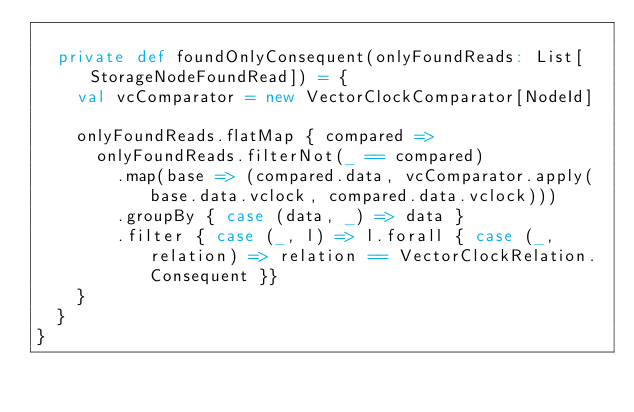Convert code to text. <code><loc_0><loc_0><loc_500><loc_500><_Scala_>
  private def foundOnlyConsequent(onlyFoundReads: List[StorageNodeFoundRead]) = {
    val vcComparator = new VectorClockComparator[NodeId]

    onlyFoundReads.flatMap { compared =>
      onlyFoundReads.filterNot(_ == compared)
        .map(base => (compared.data, vcComparator.apply(base.data.vclock, compared.data.vclock)))
        .groupBy { case (data, _) => data }
        .filter { case (_, l) => l.forall { case (_, relation) => relation == VectorClockRelation.Consequent }}
    }
  }
}
</code> 